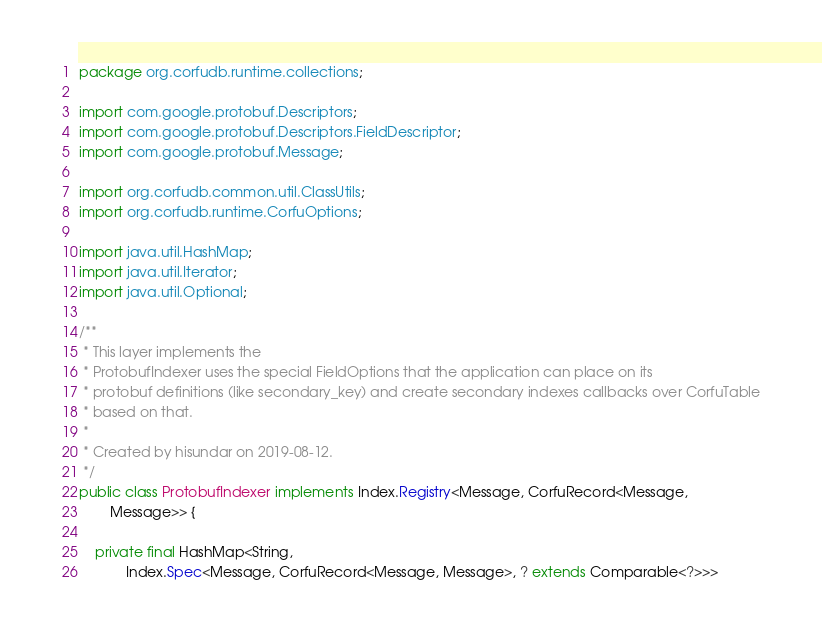<code> <loc_0><loc_0><loc_500><loc_500><_Java_>package org.corfudb.runtime.collections;

import com.google.protobuf.Descriptors;
import com.google.protobuf.Descriptors.FieldDescriptor;
import com.google.protobuf.Message;

import org.corfudb.common.util.ClassUtils;
import org.corfudb.runtime.CorfuOptions;

import java.util.HashMap;
import java.util.Iterator;
import java.util.Optional;

/**
 * This layer implements the
 * ProtobufIndexer uses the special FieldOptions that the application can place on its
 * protobuf definitions (like secondary_key) and create secondary indexes callbacks over CorfuTable
 * based on that.
 *
 * Created by hisundar on 2019-08-12.
 */
public class ProtobufIndexer implements Index.Registry<Message, CorfuRecord<Message,
        Message>> {

    private final HashMap<String,
            Index.Spec<Message, CorfuRecord<Message, Message>, ? extends Comparable<?>>></code> 